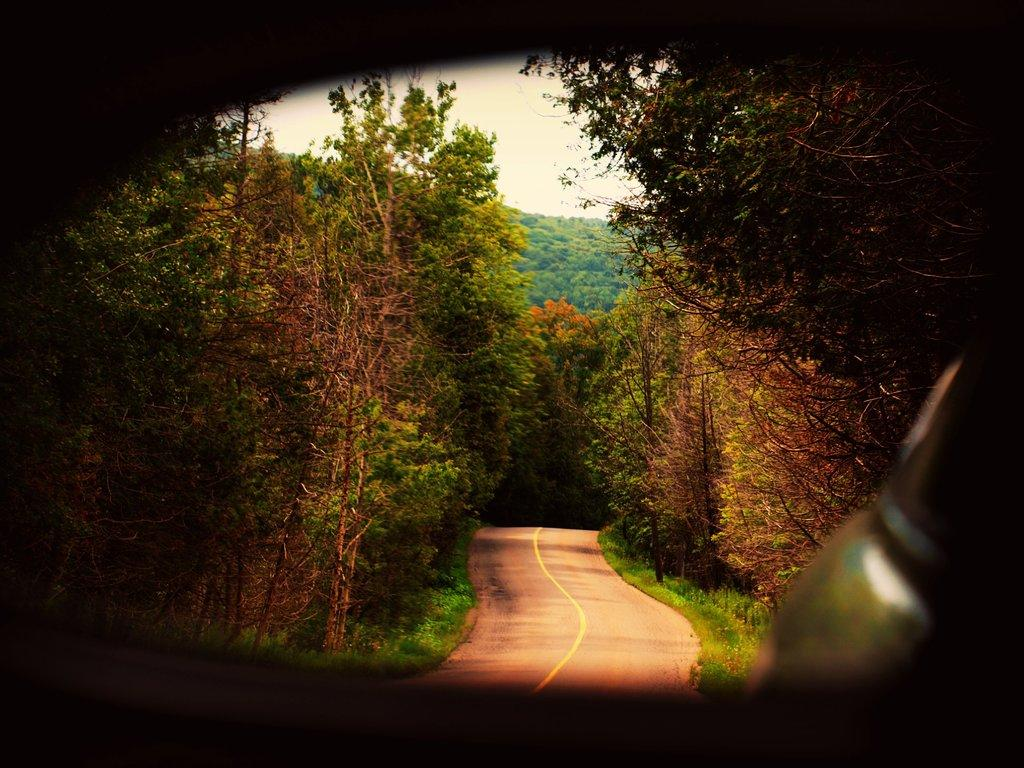What is the main feature in the middle of the image? There is a road in the middle of the image. What can be seen on either side of the road? There are trees on either side of the road. What is visible at the top of the image? The sky is visible at the top of the image. How many ducks are sitting on the table in the image? There are no ducks or tables present in the image. 